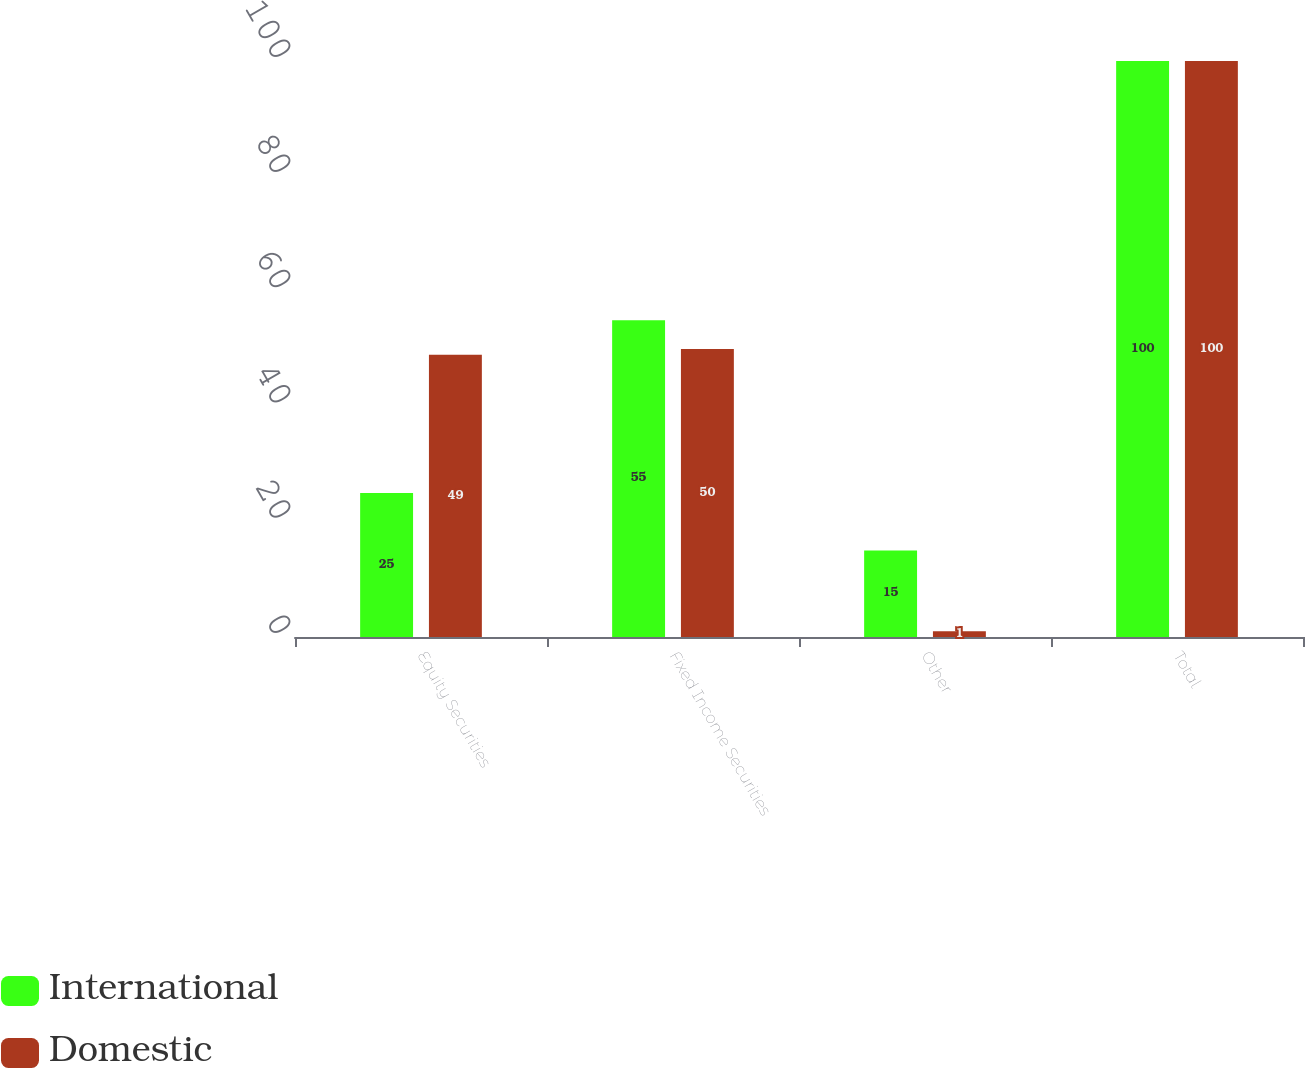Convert chart. <chart><loc_0><loc_0><loc_500><loc_500><stacked_bar_chart><ecel><fcel>Equity Securities<fcel>Fixed Income Securities<fcel>Other<fcel>Total<nl><fcel>International<fcel>25<fcel>55<fcel>15<fcel>100<nl><fcel>Domestic<fcel>49<fcel>50<fcel>1<fcel>100<nl></chart> 